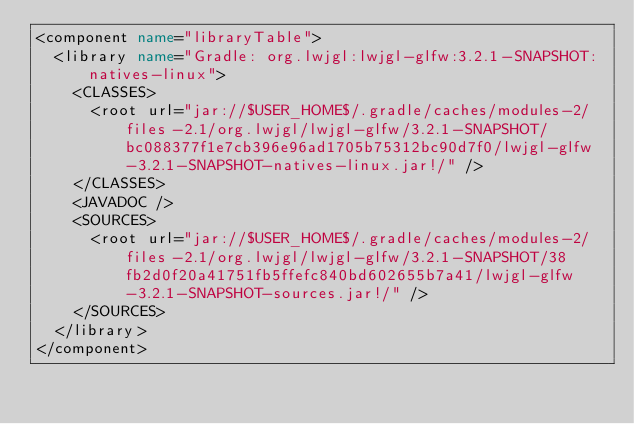<code> <loc_0><loc_0><loc_500><loc_500><_XML_><component name="libraryTable">
  <library name="Gradle: org.lwjgl:lwjgl-glfw:3.2.1-SNAPSHOT:natives-linux">
    <CLASSES>
      <root url="jar://$USER_HOME$/.gradle/caches/modules-2/files-2.1/org.lwjgl/lwjgl-glfw/3.2.1-SNAPSHOT/bc088377f1e7cb396e96ad1705b75312bc90d7f0/lwjgl-glfw-3.2.1-SNAPSHOT-natives-linux.jar!/" />
    </CLASSES>
    <JAVADOC />
    <SOURCES>
      <root url="jar://$USER_HOME$/.gradle/caches/modules-2/files-2.1/org.lwjgl/lwjgl-glfw/3.2.1-SNAPSHOT/38fb2d0f20a41751fb5ffefc840bd602655b7a41/lwjgl-glfw-3.2.1-SNAPSHOT-sources.jar!/" />
    </SOURCES>
  </library>
</component></code> 